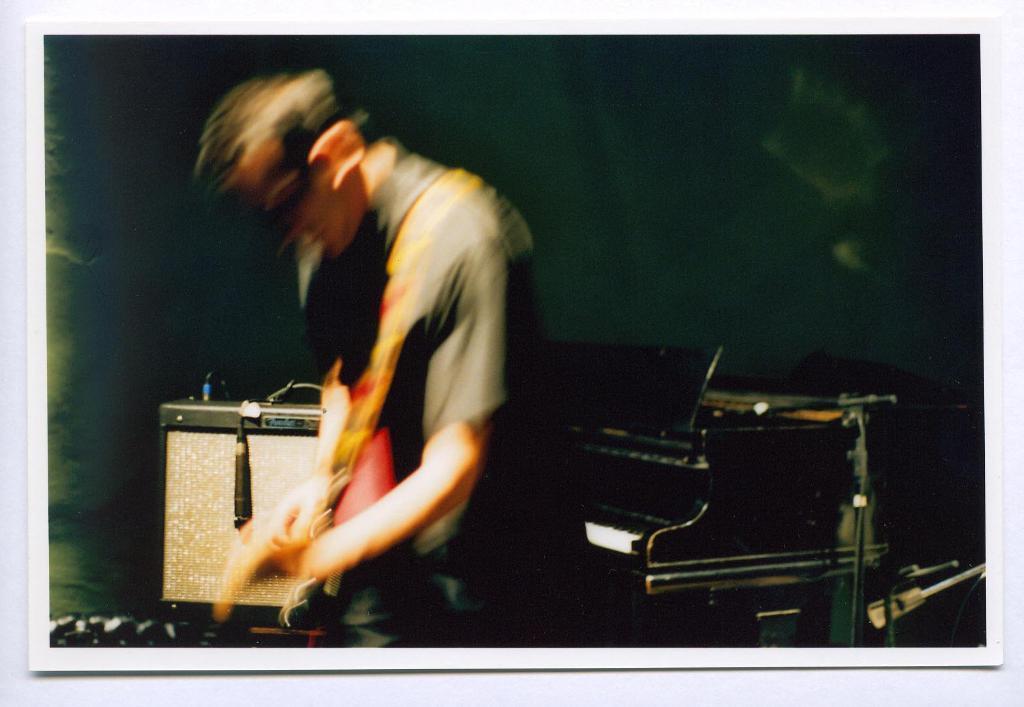Describe this image in one or two sentences. In this image I can see a man standing. In the background there is a table. It seems like this is an image clicked inside the room. 